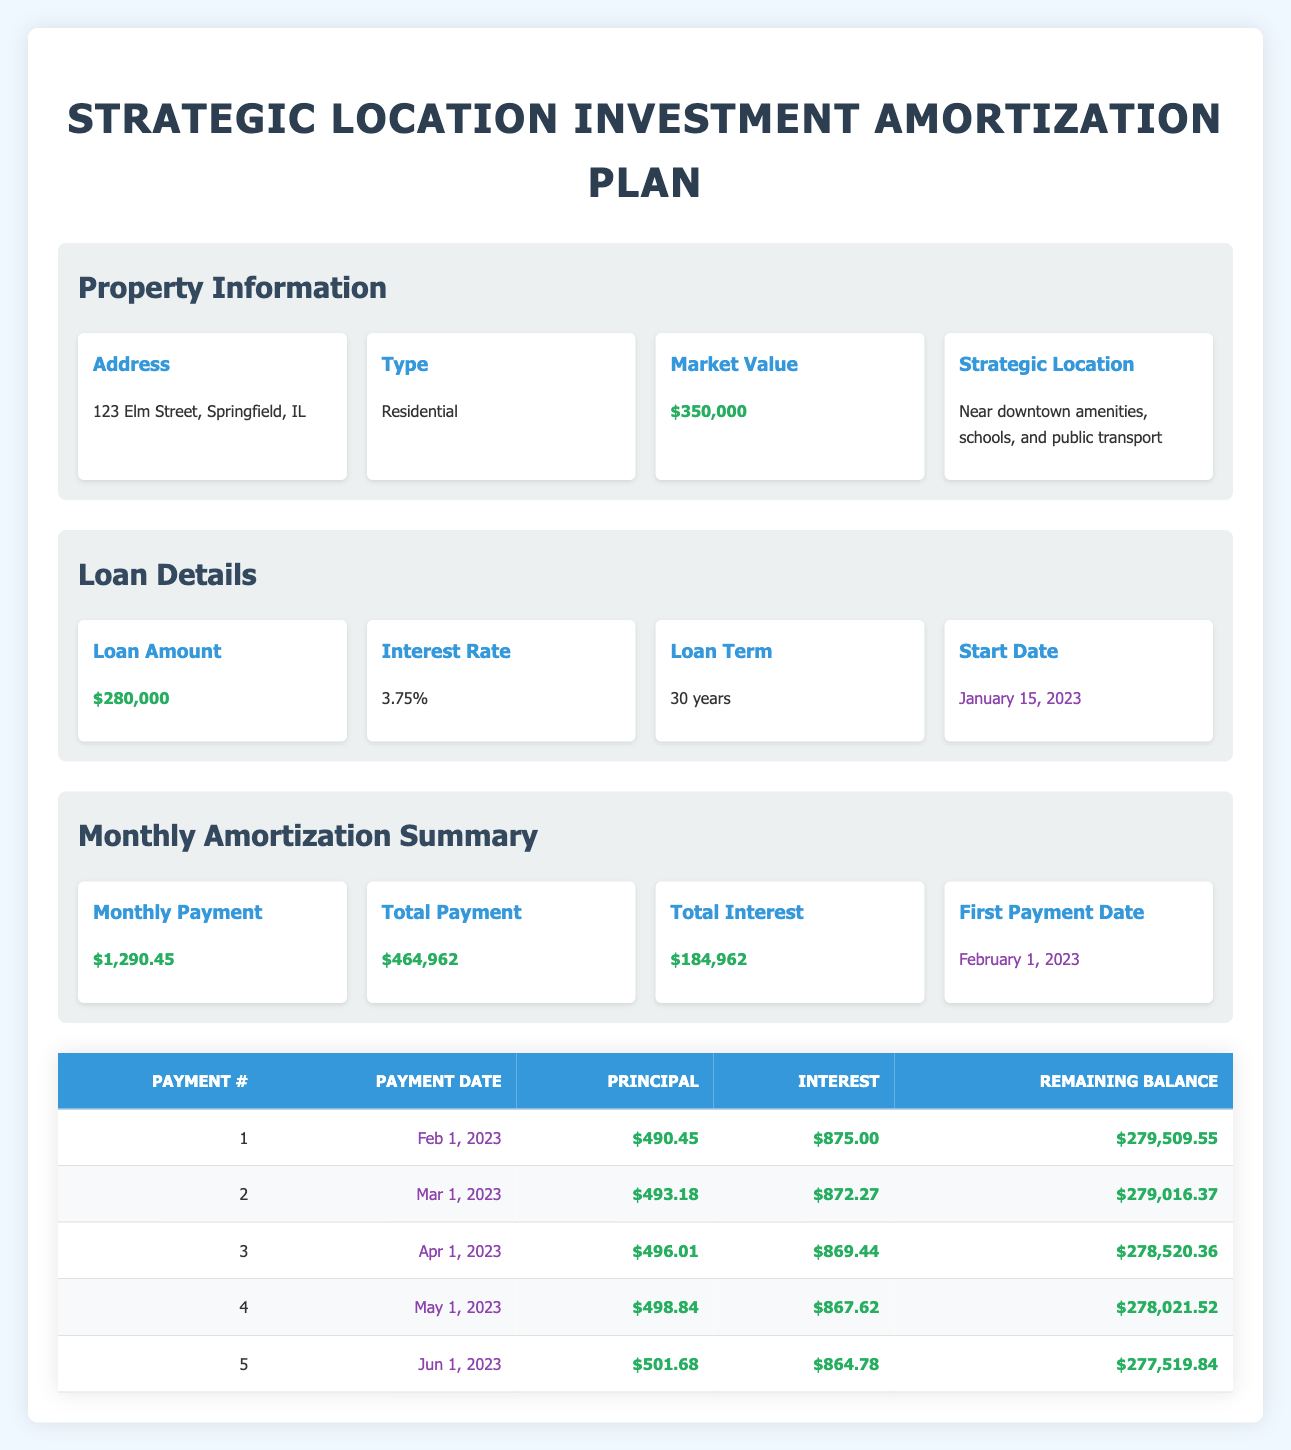What is the total payment over the life of the loan? The total payment over the life of the loan is given in the monthly amortization summary. It states that the total payment equals $464,962.
Answer: 464962 What is the monthly payment amount? The monthly payment amount can be found in the monthly amortization summary where it states the amount as $1,290.45.
Answer: 1290.45 How much is the remaining balance after the second payment? The remaining balance after the second payment can be found in the amortization schedule. Looking at the second payment row, the remaining balance is listed as $279,016.37.
Answer: 279016.37 Is the interest payment for the first month higher than the principal payment? To determine this, compare the interest payment of $875.00 with the principal of $490.45. Since $875.00 is greater than $490.45, the statement is true.
Answer: Yes What is the total amount of interest paid after the first five payments? The total interest for the first five payments can be calculated by adding the interest payments from the first five rows: $875 + $872.27 + $869.44 + $867.62 + $864.78 = $4349.11.
Answer: 4349.11 What is the average principal payment for the first five months? The principal payments for the first five months are $490.45, $493.18, $496.01, $498.84, and $501.68. To find the average, sum these values: $490.45 + $493.18 + $496.01 + $498.84 + $501.68 = $2480.16, then divide by 5. The average principal payment is $2480.16 / 5 = $496.03.
Answer: 496.03 What is the principal payment for the fifth payment compared to the interest payment? The principal payment for the fifth payment is $501.68, and the interest payment is $864.78. Since $501.68 is less than $864.78, the principal payment is lower than the interest payment.
Answer: No How much does the remaining balance decrease from the first payment to the second payment? The remaining balance after the first payment is $279,509.55 and after the second payment is $279,016.37. To find the decrease, subtract the second from the first: $279,509.55 - $279,016.37 = $493.18.
Answer: 493.18 How many total payments need to be made to fully amortize the loan? Since this loan is for 30 years and the payments are monthly, the total number of payments is calculated as 30 years * 12 months/year = 360 payments.
Answer: 360 